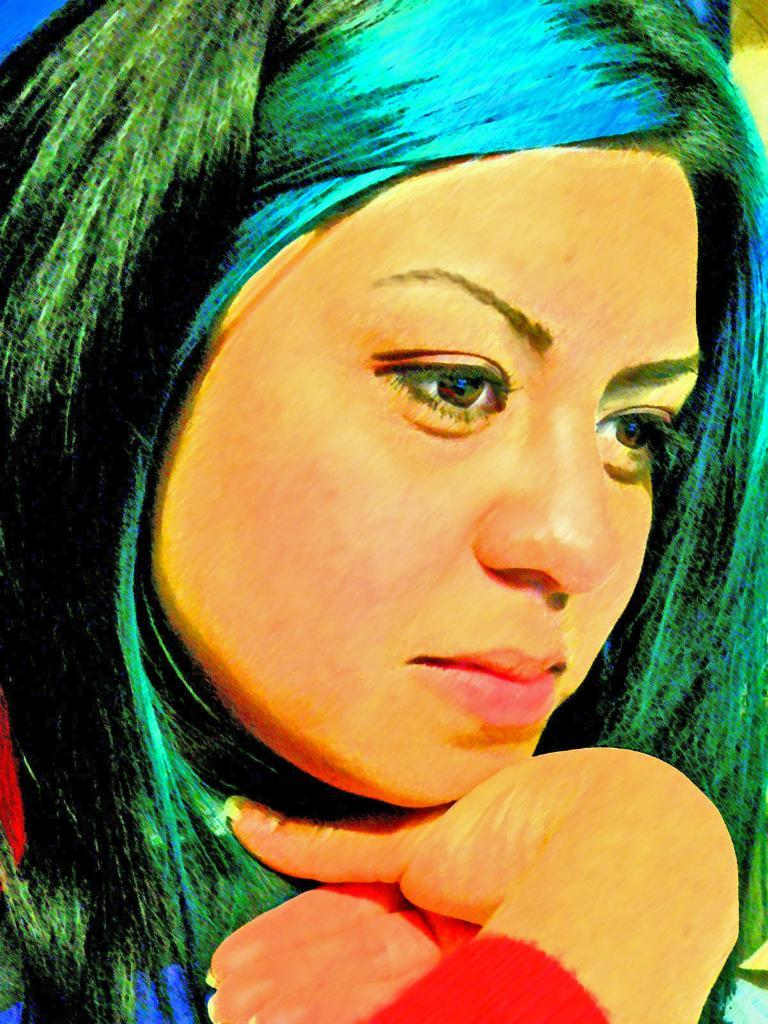What is the main subject of the image? There is a painting in the image. What does the painting depict? The painting depicts a woman. How many pies are being raked by the woman in the painting? There are no pies or rakes present in the painting; it depicts a woman. 